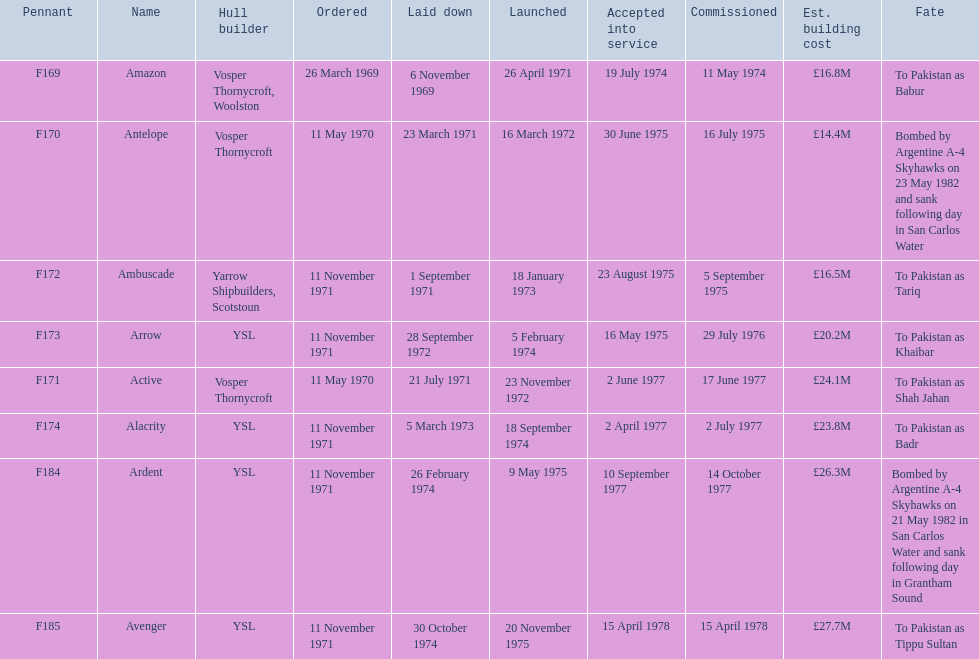Which kind of 21 frigate vessels were intended to be constructed by ysl in the 1970s? Arrow, Alacrity, Ardent, Avenger. Among these vessels, which one had the greatest projected construction cost? Avenger. Give me the full table as a dictionary. {'header': ['Pennant', 'Name', 'Hull builder', 'Ordered', 'Laid down', 'Launched', 'Accepted into service', 'Commissioned', 'Est. building cost', 'Fate'], 'rows': [['F169', 'Amazon', 'Vosper Thornycroft, Woolston', '26 March 1969', '6 November 1969', '26 April 1971', '19 July 1974', '11 May 1974', '£16.8M', 'To Pakistan as Babur'], ['F170', 'Antelope', 'Vosper Thornycroft', '11 May 1970', '23 March 1971', '16 March 1972', '30 June 1975', '16 July 1975', '£14.4M', 'Bombed by Argentine A-4 Skyhawks on 23 May 1982 and sank following day in San Carlos Water'], ['F172', 'Ambuscade', 'Yarrow Shipbuilders, Scotstoun', '11 November 1971', '1 September 1971', '18 January 1973', '23 August 1975', '5 September 1975', '£16.5M', 'To Pakistan as Tariq'], ['F173', 'Arrow', 'YSL', '11 November 1971', '28 September 1972', '5 February 1974', '16 May 1975', '29 July 1976', '£20.2M', 'To Pakistan as Khaibar'], ['F171', 'Active', 'Vosper Thornycroft', '11 May 1970', '21 July 1971', '23 November 1972', '2 June 1977', '17 June 1977', '£24.1M', 'To Pakistan as Shah Jahan'], ['F174', 'Alacrity', 'YSL', '11 November 1971', '5 March 1973', '18 September 1974', '2 April 1977', '2 July 1977', '£23.8M', 'To Pakistan as Badr'], ['F184', 'Ardent', 'YSL', '11 November 1971', '26 February 1974', '9 May 1975', '10 September 1977', '14 October 1977', '£26.3M', 'Bombed by Argentine A-4 Skyhawks on 21 May 1982 in San Carlos Water and sank following day in Grantham Sound'], ['F185', 'Avenger', 'YSL', '11 November 1971', '30 October 1974', '20 November 1975', '15 April 1978', '15 April 1978', '£27.7M', 'To Pakistan as Tippu Sultan']]} 